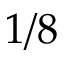<formula> <loc_0><loc_0><loc_500><loc_500>1 / 8</formula> 